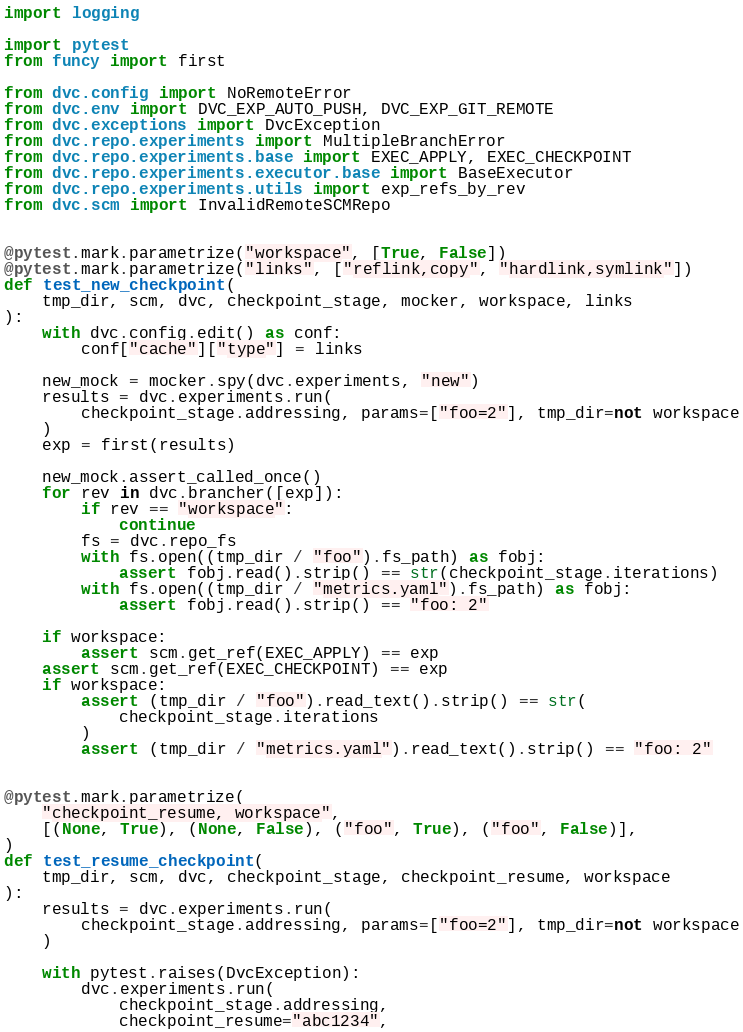<code> <loc_0><loc_0><loc_500><loc_500><_Python_>import logging

import pytest
from funcy import first

from dvc.config import NoRemoteError
from dvc.env import DVC_EXP_AUTO_PUSH, DVC_EXP_GIT_REMOTE
from dvc.exceptions import DvcException
from dvc.repo.experiments import MultipleBranchError
from dvc.repo.experiments.base import EXEC_APPLY, EXEC_CHECKPOINT
from dvc.repo.experiments.executor.base import BaseExecutor
from dvc.repo.experiments.utils import exp_refs_by_rev
from dvc.scm import InvalidRemoteSCMRepo


@pytest.mark.parametrize("workspace", [True, False])
@pytest.mark.parametrize("links", ["reflink,copy", "hardlink,symlink"])
def test_new_checkpoint(
    tmp_dir, scm, dvc, checkpoint_stage, mocker, workspace, links
):
    with dvc.config.edit() as conf:
        conf["cache"]["type"] = links

    new_mock = mocker.spy(dvc.experiments, "new")
    results = dvc.experiments.run(
        checkpoint_stage.addressing, params=["foo=2"], tmp_dir=not workspace
    )
    exp = first(results)

    new_mock.assert_called_once()
    for rev in dvc.brancher([exp]):
        if rev == "workspace":
            continue
        fs = dvc.repo_fs
        with fs.open((tmp_dir / "foo").fs_path) as fobj:
            assert fobj.read().strip() == str(checkpoint_stage.iterations)
        with fs.open((tmp_dir / "metrics.yaml").fs_path) as fobj:
            assert fobj.read().strip() == "foo: 2"

    if workspace:
        assert scm.get_ref(EXEC_APPLY) == exp
    assert scm.get_ref(EXEC_CHECKPOINT) == exp
    if workspace:
        assert (tmp_dir / "foo").read_text().strip() == str(
            checkpoint_stage.iterations
        )
        assert (tmp_dir / "metrics.yaml").read_text().strip() == "foo: 2"


@pytest.mark.parametrize(
    "checkpoint_resume, workspace",
    [(None, True), (None, False), ("foo", True), ("foo", False)],
)
def test_resume_checkpoint(
    tmp_dir, scm, dvc, checkpoint_stage, checkpoint_resume, workspace
):
    results = dvc.experiments.run(
        checkpoint_stage.addressing, params=["foo=2"], tmp_dir=not workspace
    )

    with pytest.raises(DvcException):
        dvc.experiments.run(
            checkpoint_stage.addressing,
            checkpoint_resume="abc1234",</code> 